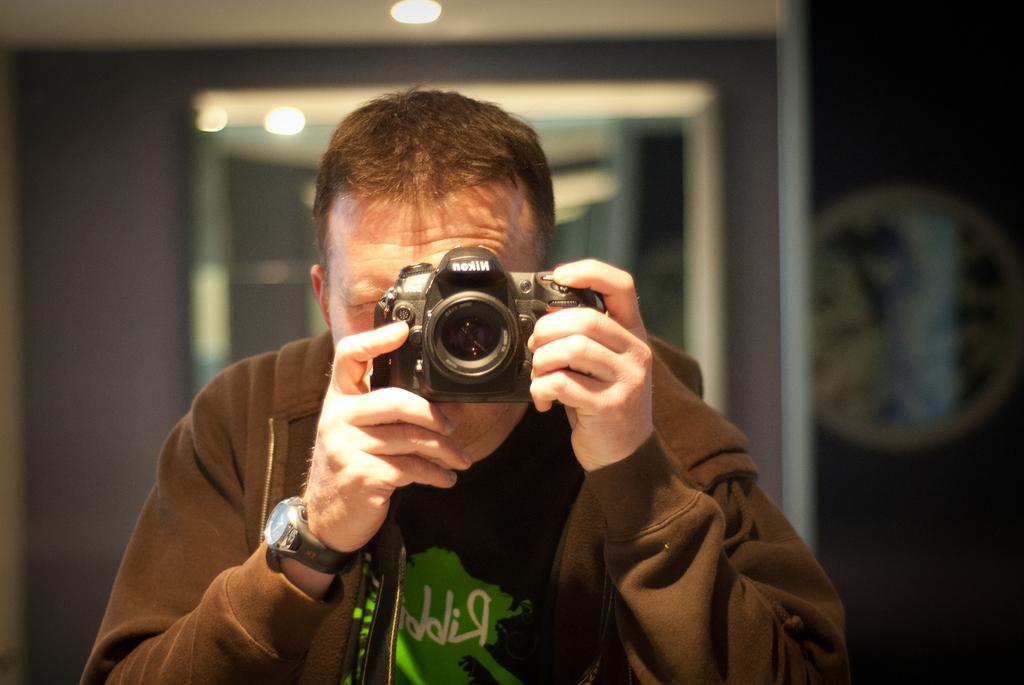Who is the main subject in the image? There is a man in the image. What is the man doing in the image? The man is holding a camera with his hands and taking a snap. Can you describe the lighting in the image? There is a light visible at the top of the image. What type of quilt is being used to limit the man's movement in the image? There is no quilt or limitation of movement present in the image; the man is simply taking a snap with a camera. 